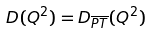Convert formula to latex. <formula><loc_0><loc_0><loc_500><loc_500>D ( Q ^ { 2 } ) = D _ { \overline { P T } } ( Q ^ { 2 } )</formula> 